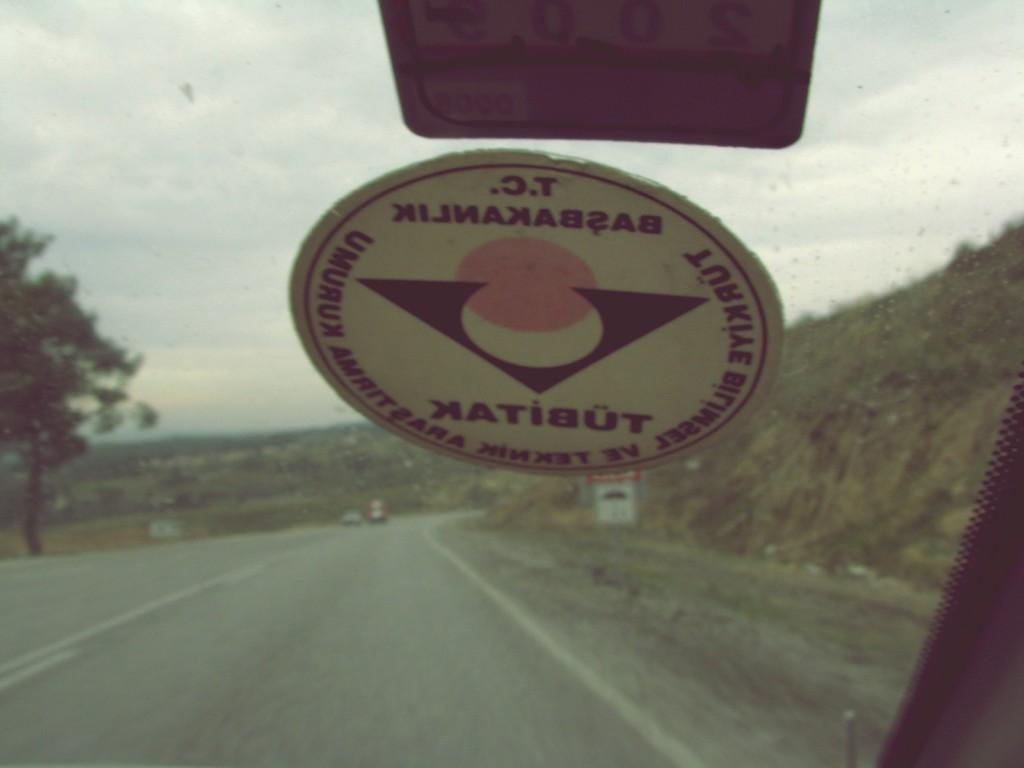What object is present in the image that can hold a liquid? There is a glass in the image. What can be seen through the glass? A tree, two vehicles, and the sky are visible through the glass. Are there any decorations or markings on the glass? Yes, there are two stickers pasted on the glass. Where is the nearest park to the location depicted in the image? The image does not provide any information about the location or the presence of a park, so it cannot be determined from the image. 